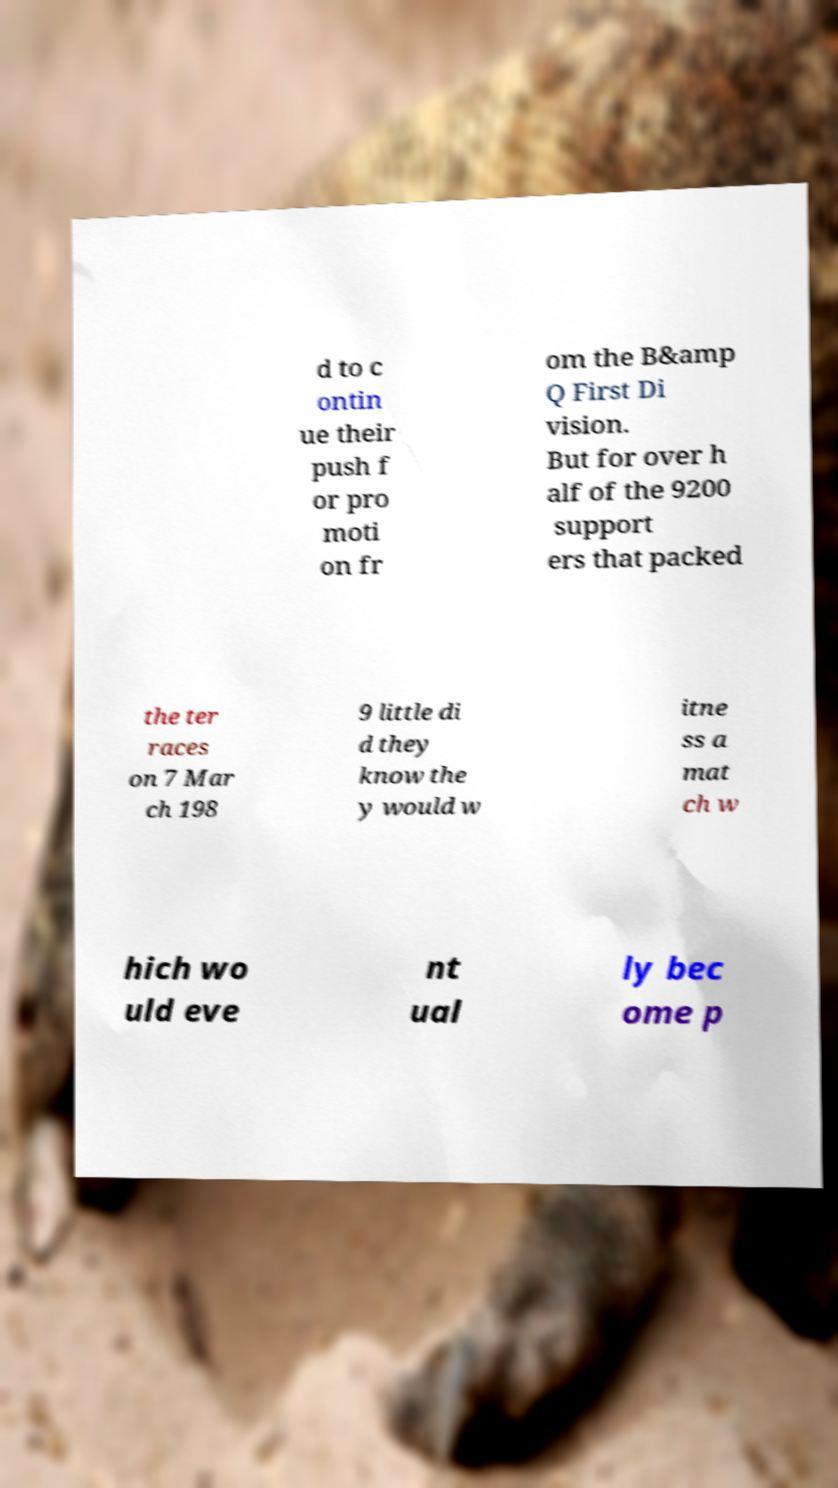Please identify and transcribe the text found in this image. d to c ontin ue their push f or pro moti on fr om the B&amp Q First Di vision. But for over h alf of the 9200 support ers that packed the ter races on 7 Mar ch 198 9 little di d they know the y would w itne ss a mat ch w hich wo uld eve nt ual ly bec ome p 